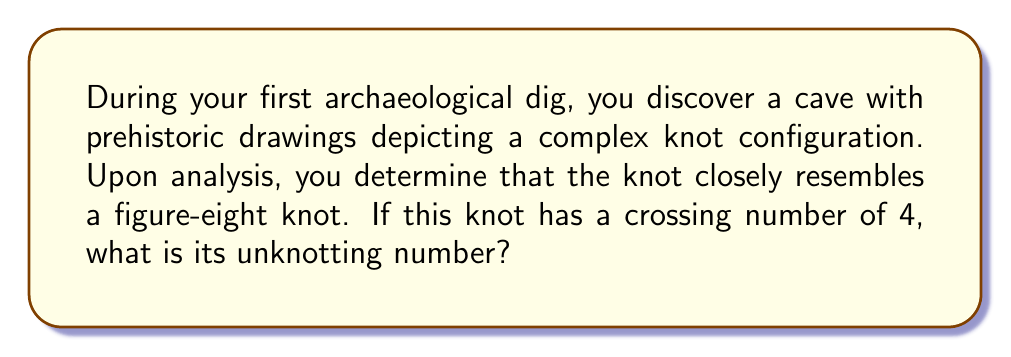Could you help me with this problem? To determine the unknotting number of the figure-eight knot, we need to follow these steps:

1. Understand the concept of unknotting number:
   The unknotting number of a knot is the minimum number of crossing changes required to transform the knot into the unknot (trivial knot).

2. Analyze the figure-eight knot:
   The figure-eight knot is one of the simplest non-trivial knots. It has a crossing number of 4, which means it has 4 crossings in its minimal diagram.

3. Consider possible unknotting sequences:
   To unknot the figure-eight knot, we need to change some of its crossings. Let's examine the knot diagram:

   [asy]
   import geometry;

   pair A = (0,0), B = (1,1), C = (2,0), D = (1,-1);
   pair E = (0.5,0.5), F = (1.5,0.5), G = (0.5,-0.5), H = (1.5,-0.5);

   draw(A--E--B--F--C--H--D--G--cycle);
   draw(E--G, dashed);
   draw(F--H, dashed);

   dot(A); dot(B); dot(C); dot(D);
   [/asy]

4. Analyze crossing changes:
   - Changing any single crossing does not unknot the figure-eight knot.
   - Changing any two crossings is sufficient to unknot it.

5. Prove minimality:
   The unknotting number cannot be 0 (as it's not already unknotted) or 1 (as changing one crossing doesn't unknot it).

6. Conclude:
   The unknotting number of the figure-eight knot is 2.

This result is significant in knot theory, as the figure-eight knot is one of the simplest non-trivial knots with a known unknotting number.
Answer: 2 